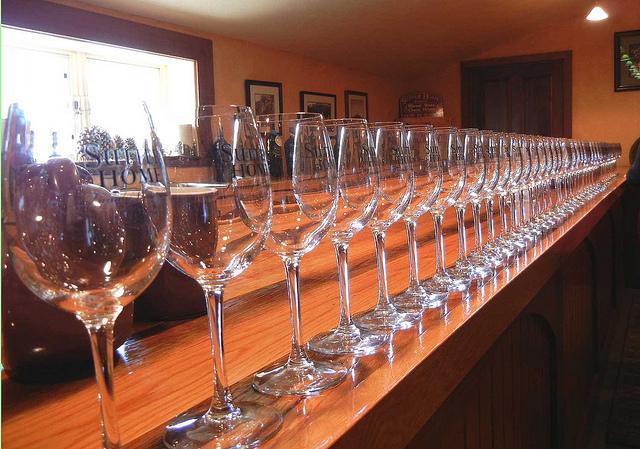What coloring is the lettering on the glasses?
Short answer required. Black. What beverage is in each glass?
Quick response, please. None. Is there likely to be milk poured into these glasses?
Concise answer only. No. Is there an overhead light above the glasses?
Be succinct. Yes. 